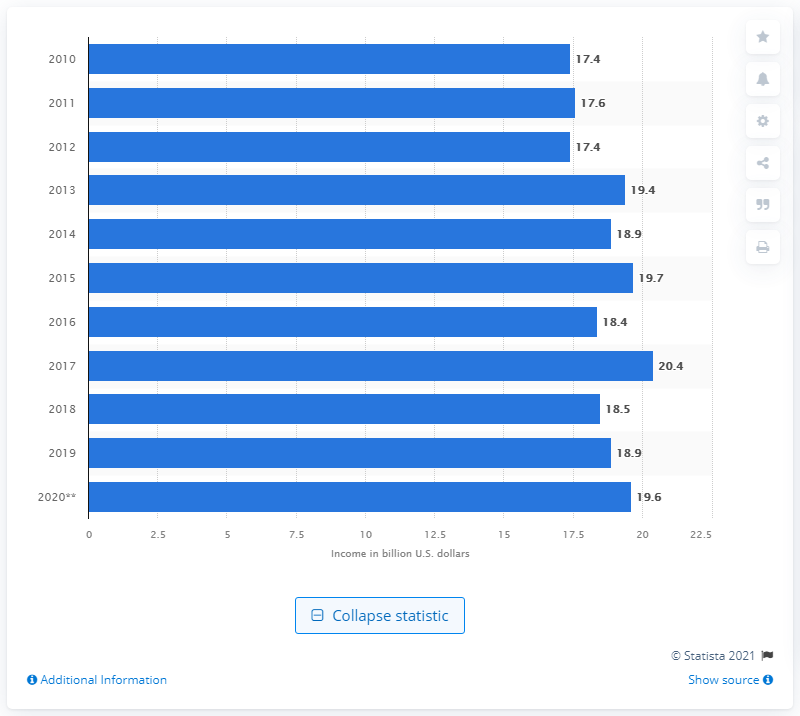Point out several critical features in this image. In 2020, the amount of money made from farming vegetables in the United States was 19.7 billion dollars. 